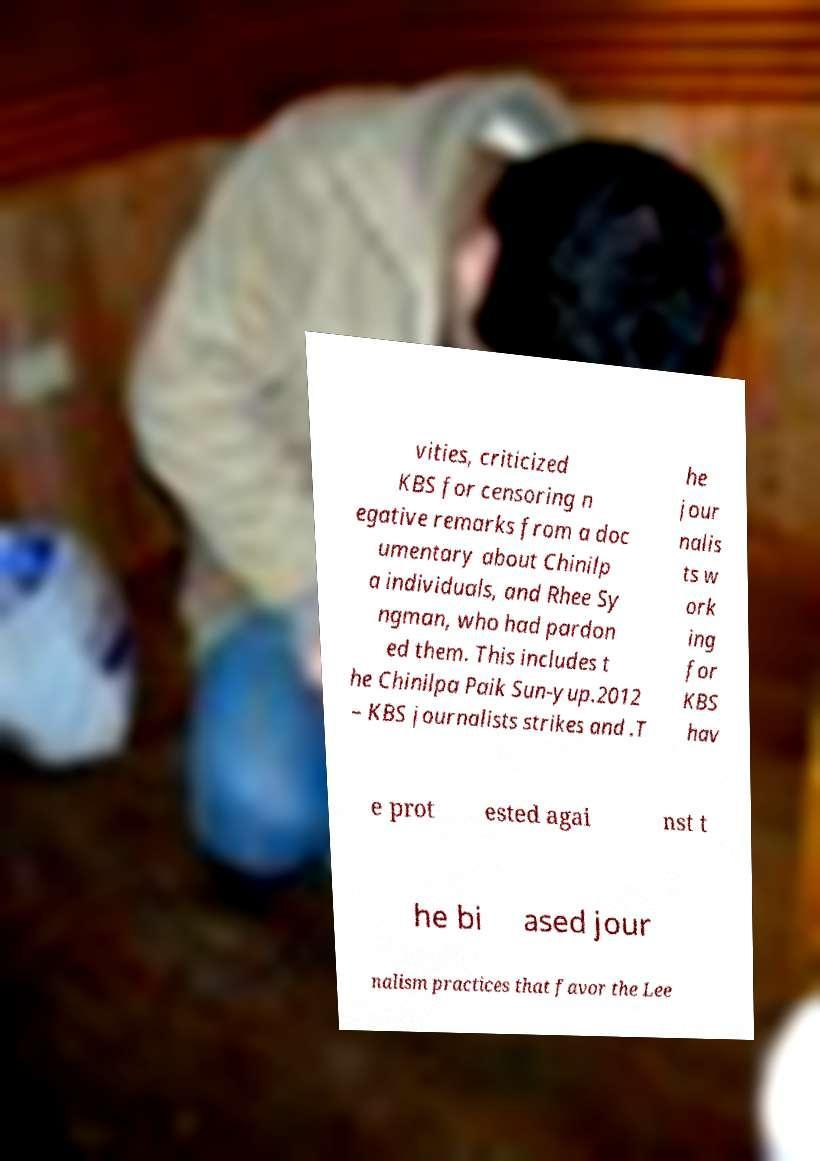There's text embedded in this image that I need extracted. Can you transcribe it verbatim? vities, criticized KBS for censoring n egative remarks from a doc umentary about Chinilp a individuals, and Rhee Sy ngman, who had pardon ed them. This includes t he Chinilpa Paik Sun-yup.2012 – KBS journalists strikes and .T he jour nalis ts w ork ing for KBS hav e prot ested agai nst t he bi ased jour nalism practices that favor the Lee 